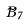<formula> <loc_0><loc_0><loc_500><loc_500>\tilde { B } _ { 7 }</formula> 